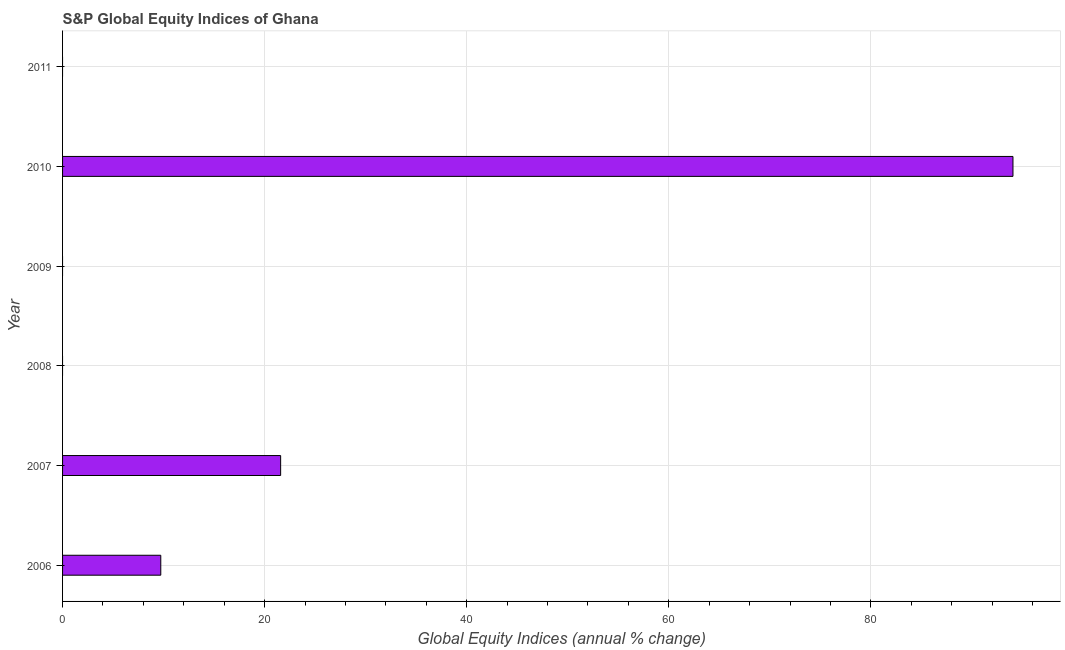What is the title of the graph?
Provide a short and direct response. S&P Global Equity Indices of Ghana. What is the label or title of the X-axis?
Provide a short and direct response. Global Equity Indices (annual % change). What is the s&p global equity indices in 2011?
Keep it short and to the point. 0. Across all years, what is the maximum s&p global equity indices?
Make the answer very short. 94.06. Across all years, what is the minimum s&p global equity indices?
Give a very brief answer. 0. What is the sum of the s&p global equity indices?
Ensure brevity in your answer.  125.37. What is the difference between the s&p global equity indices in 2007 and 2010?
Your response must be concise. -72.48. What is the average s&p global equity indices per year?
Your answer should be compact. 20.89. What is the median s&p global equity indices?
Make the answer very short. 4.86. In how many years, is the s&p global equity indices greater than 8 %?
Offer a very short reply. 3. Is the s&p global equity indices in 2006 less than that in 2007?
Offer a very short reply. Yes. What is the difference between the highest and the second highest s&p global equity indices?
Your answer should be very brief. 72.48. Is the sum of the s&p global equity indices in 2007 and 2010 greater than the maximum s&p global equity indices across all years?
Your answer should be compact. Yes. What is the difference between the highest and the lowest s&p global equity indices?
Provide a short and direct response. 94.06. How many bars are there?
Give a very brief answer. 3. Are all the bars in the graph horizontal?
Give a very brief answer. Yes. How many years are there in the graph?
Give a very brief answer. 6. What is the Global Equity Indices (annual % change) in 2006?
Offer a very short reply. 9.72. What is the Global Equity Indices (annual % change) of 2007?
Provide a short and direct response. 21.58. What is the Global Equity Indices (annual % change) in 2009?
Give a very brief answer. 0. What is the Global Equity Indices (annual % change) in 2010?
Provide a succinct answer. 94.06. What is the difference between the Global Equity Indices (annual % change) in 2006 and 2007?
Offer a terse response. -11.86. What is the difference between the Global Equity Indices (annual % change) in 2006 and 2010?
Your answer should be very brief. -84.34. What is the difference between the Global Equity Indices (annual % change) in 2007 and 2010?
Offer a terse response. -72.48. What is the ratio of the Global Equity Indices (annual % change) in 2006 to that in 2007?
Provide a short and direct response. 0.45. What is the ratio of the Global Equity Indices (annual % change) in 2006 to that in 2010?
Provide a succinct answer. 0.1. What is the ratio of the Global Equity Indices (annual % change) in 2007 to that in 2010?
Ensure brevity in your answer.  0.23. 